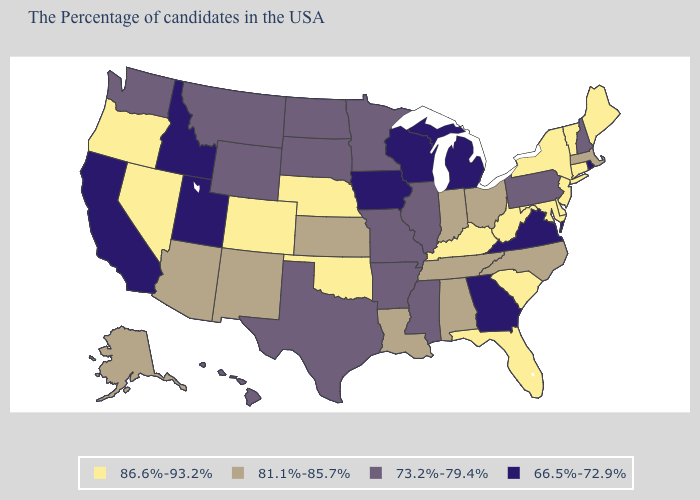Name the states that have a value in the range 73.2%-79.4%?
Give a very brief answer. New Hampshire, Pennsylvania, Illinois, Mississippi, Missouri, Arkansas, Minnesota, Texas, South Dakota, North Dakota, Wyoming, Montana, Washington, Hawaii. What is the lowest value in states that border Wisconsin?
Short answer required. 66.5%-72.9%. What is the value of West Virginia?
Quick response, please. 86.6%-93.2%. What is the value of Alaska?
Concise answer only. 81.1%-85.7%. What is the value of Utah?
Concise answer only. 66.5%-72.9%. Name the states that have a value in the range 86.6%-93.2%?
Answer briefly. Maine, Vermont, Connecticut, New York, New Jersey, Delaware, Maryland, South Carolina, West Virginia, Florida, Kentucky, Nebraska, Oklahoma, Colorado, Nevada, Oregon. Does Virginia have the lowest value in the South?
Quick response, please. Yes. What is the highest value in the West ?
Quick response, please. 86.6%-93.2%. What is the highest value in the USA?
Answer briefly. 86.6%-93.2%. Which states have the lowest value in the Northeast?
Keep it brief. Rhode Island. What is the highest value in states that border Pennsylvania?
Quick response, please. 86.6%-93.2%. Which states hav the highest value in the West?
Write a very short answer. Colorado, Nevada, Oregon. Name the states that have a value in the range 81.1%-85.7%?
Be succinct. Massachusetts, North Carolina, Ohio, Indiana, Alabama, Tennessee, Louisiana, Kansas, New Mexico, Arizona, Alaska. Does the map have missing data?
Answer briefly. No. 